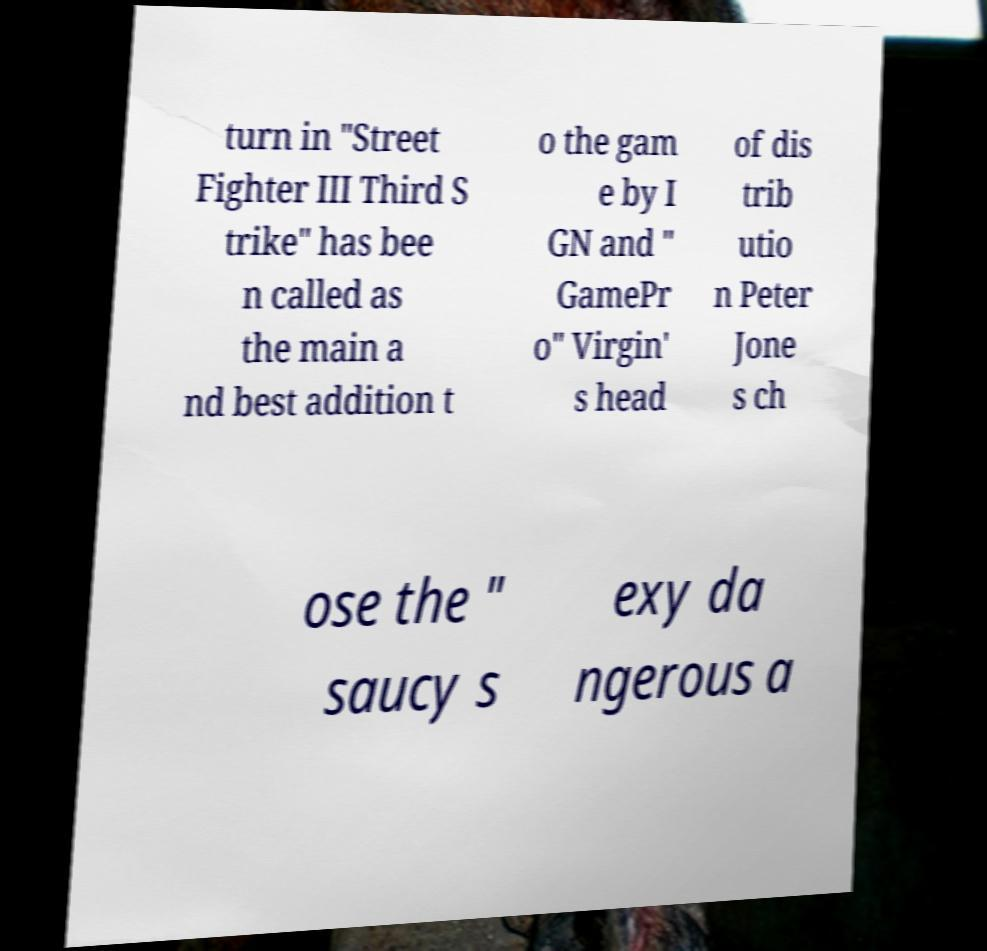Please read and relay the text visible in this image. What does it say? turn in "Street Fighter III Third S trike" has bee n called as the main a nd best addition t o the gam e by I GN and " GamePr o" Virgin' s head of dis trib utio n Peter Jone s ch ose the " saucy s exy da ngerous a 